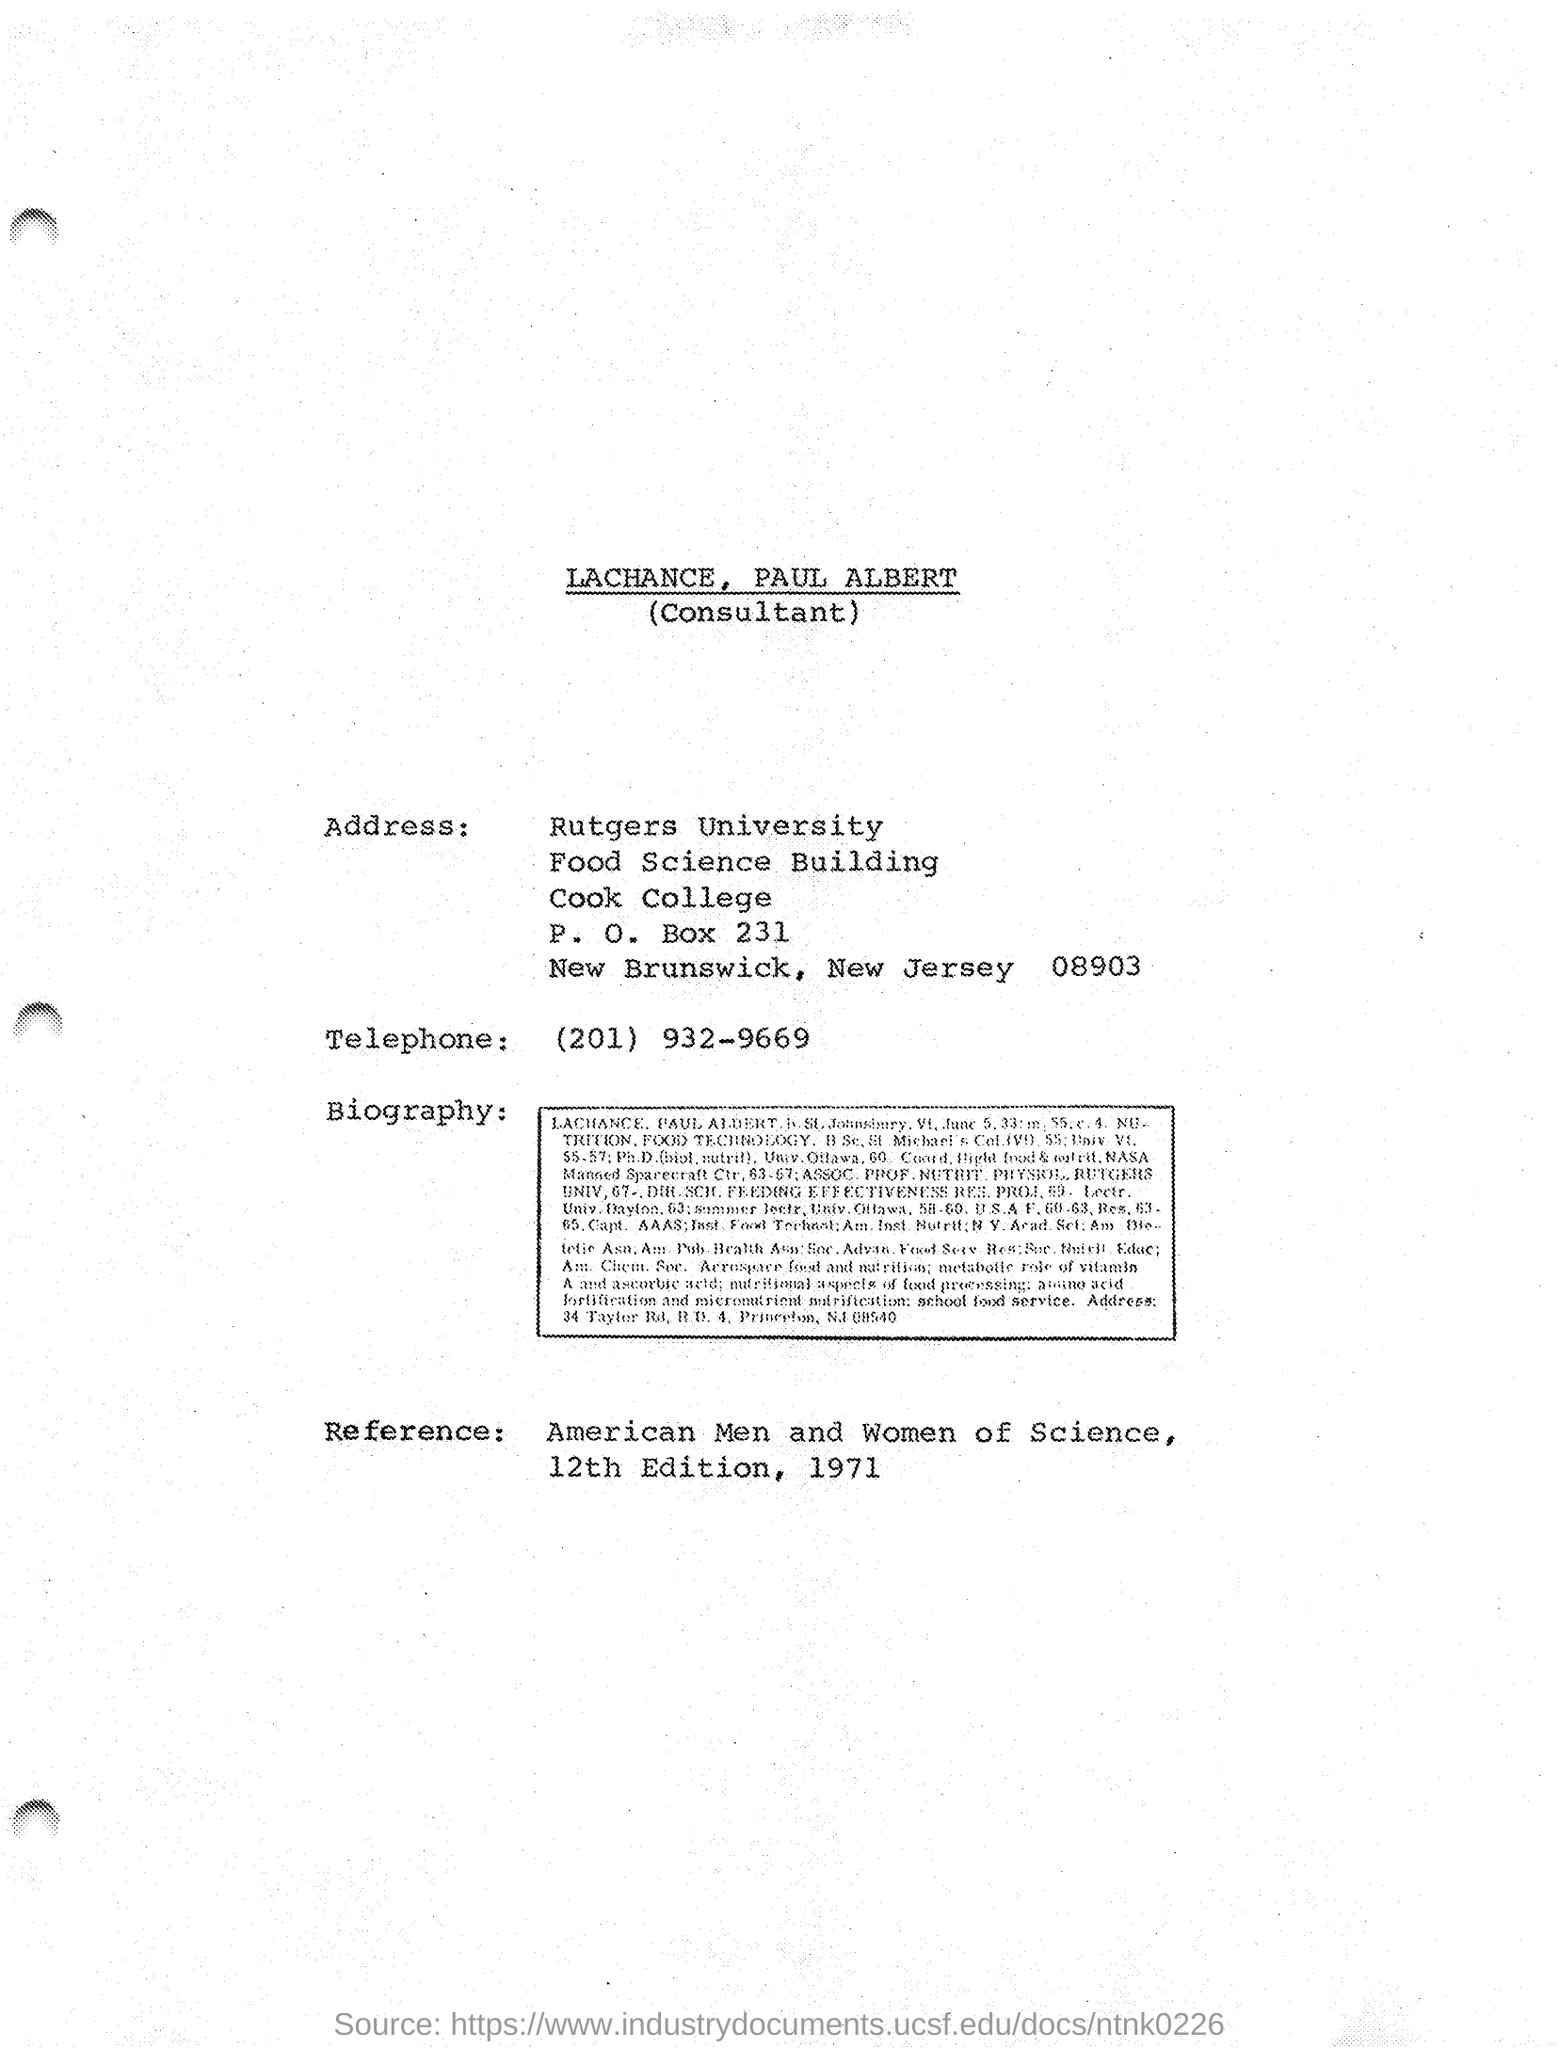Draw attention to some important aspects in this diagram. The P.O.Box number provided in the document is 231. The telephone number listed in this document is (201) 932-9669. The reference provided in this document is American Men and Women of Science, 12th Edition, which was published in 1971. The consultant mentioned in this document is Paul Albert Lachance. 